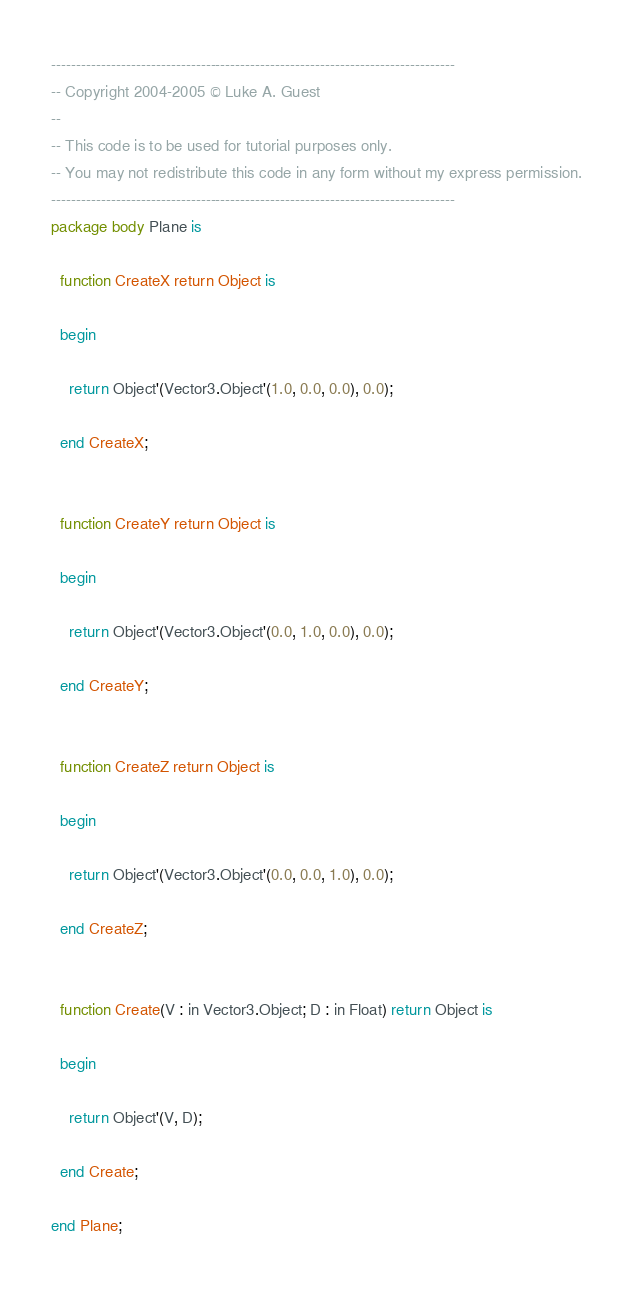Convert code to text. <code><loc_0><loc_0><loc_500><loc_500><_Ada_>---------------------------------------------------------------------------------
-- Copyright 2004-2005 © Luke A. Guest
--
-- This code is to be used for tutorial purposes only.
-- You may not redistribute this code in any form without my express permission.
---------------------------------------------------------------------------------
package body Plane is

  function CreateX return Object is
  
  begin

    return Object'(Vector3.Object'(1.0, 0.0, 0.0), 0.0);
    
  end CreateX;
  

  function CreateY return Object is
  
  begin

    return Object'(Vector3.Object'(0.0, 1.0, 0.0), 0.0);
    
  end CreateY;
  

  function CreateZ return Object is
  
  begin

    return Object'(Vector3.Object'(0.0, 0.0, 1.0), 0.0);
    
  end CreateZ;
  

  function Create(V : in Vector3.Object; D : in Float) return Object is
  
  begin
  
    return Object'(V, D);
    
  end Create;

end Plane;
</code> 